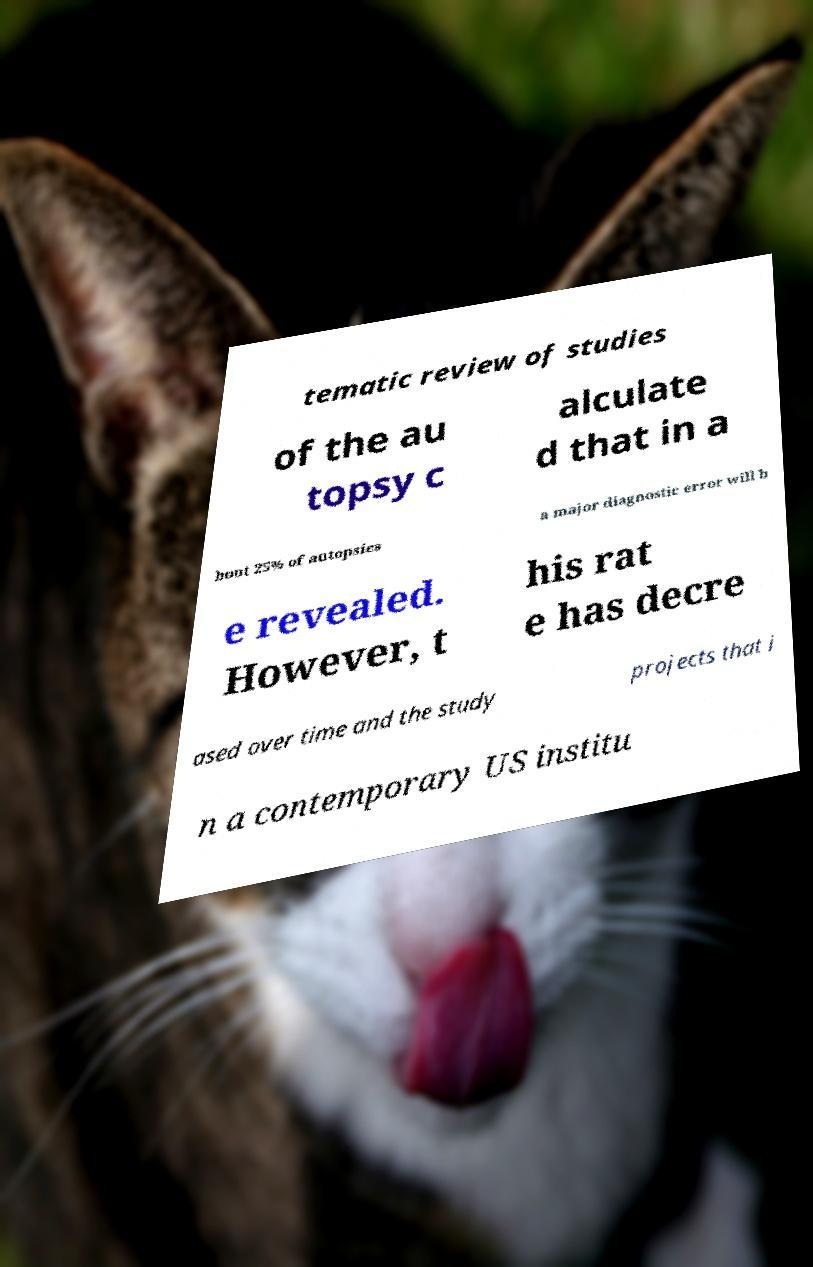For documentation purposes, I need the text within this image transcribed. Could you provide that? tematic review of studies of the au topsy c alculate d that in a bout 25% of autopsies a major diagnostic error will b e revealed. However, t his rat e has decre ased over time and the study projects that i n a contemporary US institu 